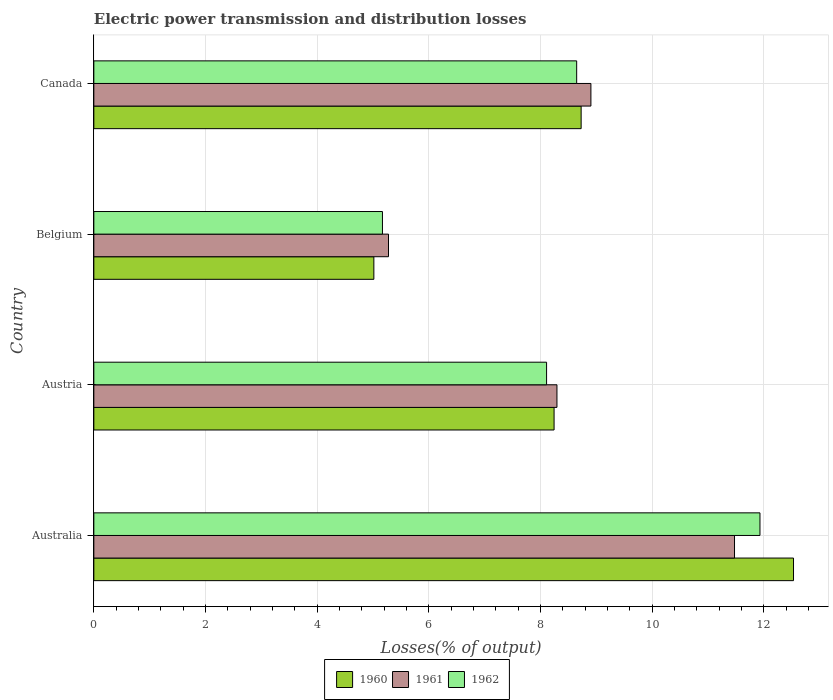How many different coloured bars are there?
Your answer should be compact. 3. Are the number of bars per tick equal to the number of legend labels?
Your answer should be very brief. Yes. Are the number of bars on each tick of the Y-axis equal?
Keep it short and to the point. Yes. What is the label of the 4th group of bars from the top?
Your response must be concise. Australia. What is the electric power transmission and distribution losses in 1961 in Australia?
Provide a short and direct response. 11.48. Across all countries, what is the maximum electric power transmission and distribution losses in 1961?
Give a very brief answer. 11.48. Across all countries, what is the minimum electric power transmission and distribution losses in 1960?
Give a very brief answer. 5.02. In which country was the electric power transmission and distribution losses in 1962 minimum?
Ensure brevity in your answer.  Belgium. What is the total electric power transmission and distribution losses in 1960 in the graph?
Your answer should be compact. 34.52. What is the difference between the electric power transmission and distribution losses in 1960 in Australia and that in Canada?
Keep it short and to the point. 3.8. What is the difference between the electric power transmission and distribution losses in 1962 in Austria and the electric power transmission and distribution losses in 1960 in Belgium?
Your answer should be very brief. 3.09. What is the average electric power transmission and distribution losses in 1960 per country?
Offer a terse response. 8.63. What is the difference between the electric power transmission and distribution losses in 1962 and electric power transmission and distribution losses in 1961 in Canada?
Give a very brief answer. -0.25. In how many countries, is the electric power transmission and distribution losses in 1961 greater than 6 %?
Ensure brevity in your answer.  3. What is the ratio of the electric power transmission and distribution losses in 1961 in Austria to that in Canada?
Provide a succinct answer. 0.93. Is the difference between the electric power transmission and distribution losses in 1962 in Australia and Austria greater than the difference between the electric power transmission and distribution losses in 1961 in Australia and Austria?
Keep it short and to the point. Yes. What is the difference between the highest and the second highest electric power transmission and distribution losses in 1962?
Offer a very short reply. 3.28. What is the difference between the highest and the lowest electric power transmission and distribution losses in 1962?
Make the answer very short. 6.76. Is the sum of the electric power transmission and distribution losses in 1961 in Austria and Canada greater than the maximum electric power transmission and distribution losses in 1962 across all countries?
Make the answer very short. Yes. What does the 3rd bar from the bottom in Belgium represents?
Ensure brevity in your answer.  1962. How many countries are there in the graph?
Your answer should be compact. 4. How many legend labels are there?
Your answer should be very brief. 3. What is the title of the graph?
Make the answer very short. Electric power transmission and distribution losses. What is the label or title of the X-axis?
Offer a very short reply. Losses(% of output). What is the Losses(% of output) in 1960 in Australia?
Offer a terse response. 12.53. What is the Losses(% of output) of 1961 in Australia?
Provide a succinct answer. 11.48. What is the Losses(% of output) in 1962 in Australia?
Make the answer very short. 11.93. What is the Losses(% of output) of 1960 in Austria?
Your answer should be very brief. 8.24. What is the Losses(% of output) in 1961 in Austria?
Ensure brevity in your answer.  8.3. What is the Losses(% of output) of 1962 in Austria?
Offer a very short reply. 8.11. What is the Losses(% of output) of 1960 in Belgium?
Offer a very short reply. 5.02. What is the Losses(% of output) in 1961 in Belgium?
Provide a short and direct response. 5.28. What is the Losses(% of output) in 1962 in Belgium?
Your answer should be compact. 5.17. What is the Losses(% of output) of 1960 in Canada?
Your answer should be compact. 8.73. What is the Losses(% of output) of 1961 in Canada?
Provide a short and direct response. 8.9. What is the Losses(% of output) of 1962 in Canada?
Your answer should be very brief. 8.65. Across all countries, what is the maximum Losses(% of output) in 1960?
Offer a terse response. 12.53. Across all countries, what is the maximum Losses(% of output) in 1961?
Ensure brevity in your answer.  11.48. Across all countries, what is the maximum Losses(% of output) in 1962?
Ensure brevity in your answer.  11.93. Across all countries, what is the minimum Losses(% of output) in 1960?
Provide a short and direct response. 5.02. Across all countries, what is the minimum Losses(% of output) of 1961?
Make the answer very short. 5.28. Across all countries, what is the minimum Losses(% of output) of 1962?
Give a very brief answer. 5.17. What is the total Losses(% of output) in 1960 in the graph?
Offer a terse response. 34.52. What is the total Losses(% of output) of 1961 in the graph?
Make the answer very short. 33.95. What is the total Losses(% of output) of 1962 in the graph?
Make the answer very short. 33.86. What is the difference between the Losses(% of output) of 1960 in Australia and that in Austria?
Offer a very short reply. 4.29. What is the difference between the Losses(% of output) of 1961 in Australia and that in Austria?
Your answer should be very brief. 3.18. What is the difference between the Losses(% of output) of 1962 in Australia and that in Austria?
Keep it short and to the point. 3.82. What is the difference between the Losses(% of output) of 1960 in Australia and that in Belgium?
Give a very brief answer. 7.52. What is the difference between the Losses(% of output) in 1961 in Australia and that in Belgium?
Give a very brief answer. 6.2. What is the difference between the Losses(% of output) of 1962 in Australia and that in Belgium?
Offer a very short reply. 6.76. What is the difference between the Losses(% of output) in 1960 in Australia and that in Canada?
Keep it short and to the point. 3.8. What is the difference between the Losses(% of output) in 1961 in Australia and that in Canada?
Make the answer very short. 2.57. What is the difference between the Losses(% of output) in 1962 in Australia and that in Canada?
Offer a terse response. 3.28. What is the difference between the Losses(% of output) in 1960 in Austria and that in Belgium?
Offer a very short reply. 3.23. What is the difference between the Losses(% of output) in 1961 in Austria and that in Belgium?
Offer a very short reply. 3.02. What is the difference between the Losses(% of output) of 1962 in Austria and that in Belgium?
Provide a short and direct response. 2.94. What is the difference between the Losses(% of output) in 1960 in Austria and that in Canada?
Offer a very short reply. -0.48. What is the difference between the Losses(% of output) in 1961 in Austria and that in Canada?
Provide a succinct answer. -0.61. What is the difference between the Losses(% of output) in 1962 in Austria and that in Canada?
Offer a very short reply. -0.54. What is the difference between the Losses(% of output) of 1960 in Belgium and that in Canada?
Provide a short and direct response. -3.71. What is the difference between the Losses(% of output) in 1961 in Belgium and that in Canada?
Offer a terse response. -3.63. What is the difference between the Losses(% of output) of 1962 in Belgium and that in Canada?
Provide a succinct answer. -3.48. What is the difference between the Losses(% of output) in 1960 in Australia and the Losses(% of output) in 1961 in Austria?
Ensure brevity in your answer.  4.24. What is the difference between the Losses(% of output) of 1960 in Australia and the Losses(% of output) of 1962 in Austria?
Offer a terse response. 4.42. What is the difference between the Losses(% of output) in 1961 in Australia and the Losses(% of output) in 1962 in Austria?
Your answer should be very brief. 3.37. What is the difference between the Losses(% of output) of 1960 in Australia and the Losses(% of output) of 1961 in Belgium?
Make the answer very short. 7.25. What is the difference between the Losses(% of output) in 1960 in Australia and the Losses(% of output) in 1962 in Belgium?
Your response must be concise. 7.36. What is the difference between the Losses(% of output) in 1961 in Australia and the Losses(% of output) in 1962 in Belgium?
Offer a very short reply. 6.31. What is the difference between the Losses(% of output) in 1960 in Australia and the Losses(% of output) in 1961 in Canada?
Your answer should be compact. 3.63. What is the difference between the Losses(% of output) in 1960 in Australia and the Losses(% of output) in 1962 in Canada?
Give a very brief answer. 3.88. What is the difference between the Losses(% of output) of 1961 in Australia and the Losses(% of output) of 1962 in Canada?
Give a very brief answer. 2.83. What is the difference between the Losses(% of output) in 1960 in Austria and the Losses(% of output) in 1961 in Belgium?
Offer a very short reply. 2.97. What is the difference between the Losses(% of output) of 1960 in Austria and the Losses(% of output) of 1962 in Belgium?
Your response must be concise. 3.07. What is the difference between the Losses(% of output) in 1961 in Austria and the Losses(% of output) in 1962 in Belgium?
Provide a short and direct response. 3.13. What is the difference between the Losses(% of output) in 1960 in Austria and the Losses(% of output) in 1961 in Canada?
Give a very brief answer. -0.66. What is the difference between the Losses(% of output) of 1960 in Austria and the Losses(% of output) of 1962 in Canada?
Provide a short and direct response. -0.4. What is the difference between the Losses(% of output) in 1961 in Austria and the Losses(% of output) in 1962 in Canada?
Keep it short and to the point. -0.35. What is the difference between the Losses(% of output) in 1960 in Belgium and the Losses(% of output) in 1961 in Canada?
Make the answer very short. -3.89. What is the difference between the Losses(% of output) in 1960 in Belgium and the Losses(% of output) in 1962 in Canada?
Ensure brevity in your answer.  -3.63. What is the difference between the Losses(% of output) of 1961 in Belgium and the Losses(% of output) of 1962 in Canada?
Keep it short and to the point. -3.37. What is the average Losses(% of output) of 1960 per country?
Provide a succinct answer. 8.63. What is the average Losses(% of output) of 1961 per country?
Provide a succinct answer. 8.49. What is the average Losses(% of output) in 1962 per country?
Keep it short and to the point. 8.46. What is the difference between the Losses(% of output) in 1960 and Losses(% of output) in 1961 in Australia?
Make the answer very short. 1.06. What is the difference between the Losses(% of output) in 1960 and Losses(% of output) in 1962 in Australia?
Provide a short and direct response. 0.6. What is the difference between the Losses(% of output) in 1961 and Losses(% of output) in 1962 in Australia?
Offer a very short reply. -0.46. What is the difference between the Losses(% of output) of 1960 and Losses(% of output) of 1961 in Austria?
Offer a terse response. -0.05. What is the difference between the Losses(% of output) of 1960 and Losses(% of output) of 1962 in Austria?
Provide a short and direct response. 0.13. What is the difference between the Losses(% of output) in 1961 and Losses(% of output) in 1962 in Austria?
Your answer should be very brief. 0.19. What is the difference between the Losses(% of output) in 1960 and Losses(% of output) in 1961 in Belgium?
Your answer should be compact. -0.26. What is the difference between the Losses(% of output) of 1960 and Losses(% of output) of 1962 in Belgium?
Provide a short and direct response. -0.15. What is the difference between the Losses(% of output) in 1961 and Losses(% of output) in 1962 in Belgium?
Provide a short and direct response. 0.11. What is the difference between the Losses(% of output) in 1960 and Losses(% of output) in 1961 in Canada?
Your response must be concise. -0.17. What is the difference between the Losses(% of output) in 1960 and Losses(% of output) in 1962 in Canada?
Provide a succinct answer. 0.08. What is the difference between the Losses(% of output) in 1961 and Losses(% of output) in 1962 in Canada?
Provide a short and direct response. 0.25. What is the ratio of the Losses(% of output) in 1960 in Australia to that in Austria?
Your response must be concise. 1.52. What is the ratio of the Losses(% of output) of 1961 in Australia to that in Austria?
Keep it short and to the point. 1.38. What is the ratio of the Losses(% of output) in 1962 in Australia to that in Austria?
Keep it short and to the point. 1.47. What is the ratio of the Losses(% of output) in 1960 in Australia to that in Belgium?
Make the answer very short. 2.5. What is the ratio of the Losses(% of output) in 1961 in Australia to that in Belgium?
Make the answer very short. 2.17. What is the ratio of the Losses(% of output) in 1962 in Australia to that in Belgium?
Offer a very short reply. 2.31. What is the ratio of the Losses(% of output) of 1960 in Australia to that in Canada?
Your answer should be compact. 1.44. What is the ratio of the Losses(% of output) of 1961 in Australia to that in Canada?
Make the answer very short. 1.29. What is the ratio of the Losses(% of output) in 1962 in Australia to that in Canada?
Provide a short and direct response. 1.38. What is the ratio of the Losses(% of output) in 1960 in Austria to that in Belgium?
Make the answer very short. 1.64. What is the ratio of the Losses(% of output) in 1961 in Austria to that in Belgium?
Your response must be concise. 1.57. What is the ratio of the Losses(% of output) of 1962 in Austria to that in Belgium?
Offer a terse response. 1.57. What is the ratio of the Losses(% of output) in 1960 in Austria to that in Canada?
Your answer should be compact. 0.94. What is the ratio of the Losses(% of output) in 1961 in Austria to that in Canada?
Keep it short and to the point. 0.93. What is the ratio of the Losses(% of output) in 1962 in Austria to that in Canada?
Offer a very short reply. 0.94. What is the ratio of the Losses(% of output) in 1960 in Belgium to that in Canada?
Your answer should be very brief. 0.57. What is the ratio of the Losses(% of output) in 1961 in Belgium to that in Canada?
Your answer should be compact. 0.59. What is the ratio of the Losses(% of output) in 1962 in Belgium to that in Canada?
Give a very brief answer. 0.6. What is the difference between the highest and the second highest Losses(% of output) of 1960?
Your answer should be very brief. 3.8. What is the difference between the highest and the second highest Losses(% of output) of 1961?
Your answer should be very brief. 2.57. What is the difference between the highest and the second highest Losses(% of output) of 1962?
Keep it short and to the point. 3.28. What is the difference between the highest and the lowest Losses(% of output) of 1960?
Provide a short and direct response. 7.52. What is the difference between the highest and the lowest Losses(% of output) of 1961?
Keep it short and to the point. 6.2. What is the difference between the highest and the lowest Losses(% of output) in 1962?
Keep it short and to the point. 6.76. 